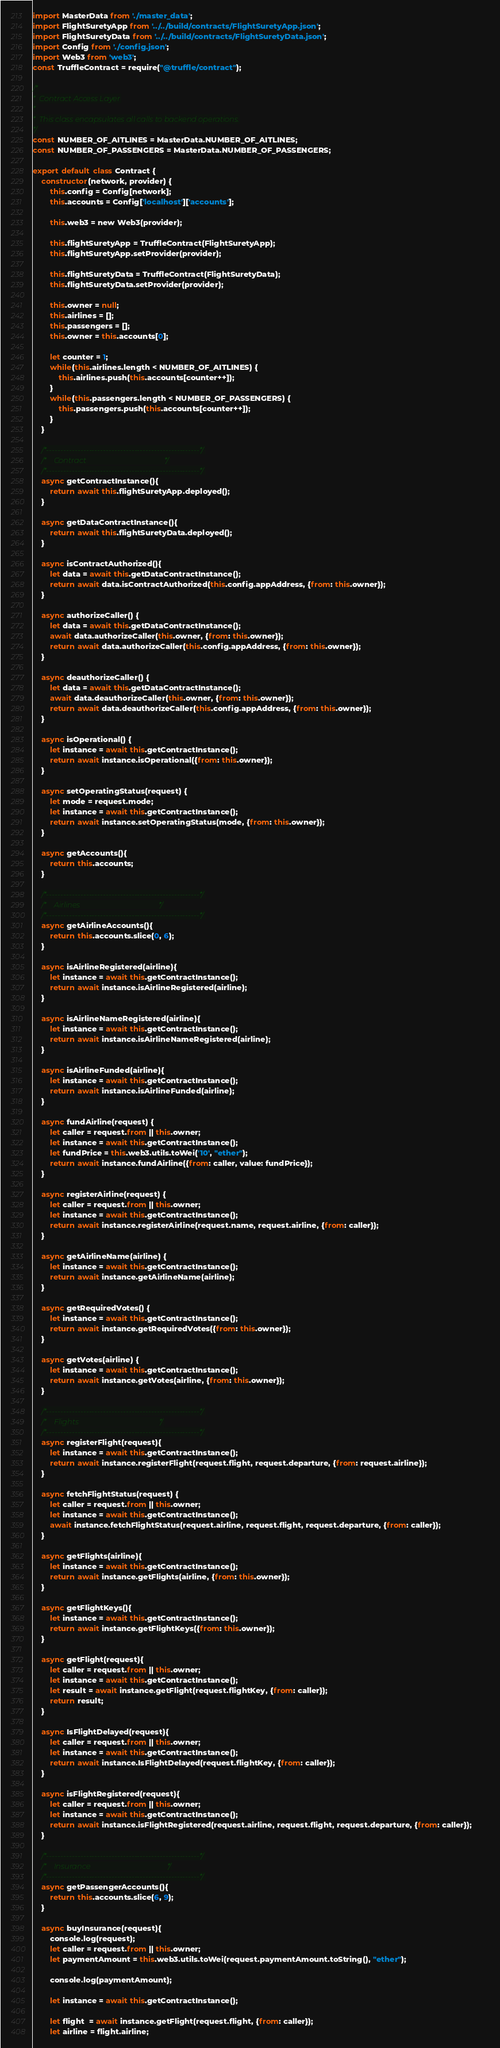Convert code to text. <code><loc_0><loc_0><loc_500><loc_500><_JavaScript_>import MasterData from './master_data';
import FlightSuretyApp from '../../build/contracts/FlightSuretyApp.json';
import FlightSuretyData from '../../build/contracts/FlightSuretyData.json';
import Config from './config.json';
import Web3 from 'web3';
const TruffleContract = require("@truffle/contract");

/*
*  Contract Access Layer
*
*  This class encapsulates all calls to backend operations.
*/
const NUMBER_OF_AITLINES = MasterData.NUMBER_OF_AITLINES;
const NUMBER_OF_PASSENGERS = MasterData.NUMBER_OF_PASSENGERS;

export default class Contract {
    constructor(network, provider) {
        this.config = Config[network];
        this.accounts = Config['localhost']['accounts'];

        this.web3 = new Web3(provider);

        this.flightSuretyApp = TruffleContract(FlightSuretyApp);
        this.flightSuretyApp.setProvider(provider);

        this.flightSuretyData = TruffleContract(FlightSuretyData);
        this.flightSuretyData.setProvider(provider);

        this.owner = null;
        this.airlines = [];
        this.passengers = [];
        this.owner = this.accounts[0];

        let counter = 1;
        while(this.airlines.length < NUMBER_OF_AITLINES) {
            this.airlines.push(this.accounts[counter++]);
        }
        while(this.passengers.length < NUMBER_OF_PASSENGERS) {
            this.passengers.push(this.accounts[counter++]);
        }
    }

    /*------------------------------------------------------*/
    /*    Contract                                          */
    /*------------------------------------------------------*/    
    async getContractInstance(){
        return await this.flightSuretyApp.deployed(); 
    }

    async getDataContractInstance(){
        return await this.flightSuretyData.deployed(); 
    }

    async isContractAuthorized(){
        let data = await this.getDataContractInstance();
        return await data.isContractAuthorized(this.config.appAddress, {from: this.owner});       
    }

    async authorizeCaller() {   
        let data = await this.getDataContractInstance();
        await data.authorizeCaller(this.owner, {from: this.owner});
        return await data.authorizeCaller(this.config.appAddress, {from: this.owner});
    }

    async deauthorizeCaller() {
        let data = await this.getDataContractInstance();
        await data.deauthorizeCaller(this.owner, {from: this.owner});
        return await data.deauthorizeCaller(this.config.appAddress, {from: this.owner});
    }    

    async isOperational() {
        let instance = await this.getContractInstance();
        return await instance.isOperational({from: this.owner});
    }

    async setOperatingStatus(request) {
        let mode = request.mode;
        let instance = await this.getContractInstance();
        return await instance.setOperatingStatus(mode, {from: this.owner});
    }

    async getAccounts(){
        return this.accounts;
    }

    /*------------------------------------------------------*/
    /*    Airlines                                          */
    /*------------------------------------------------------*/    
    async getAirlineAccounts(){
        return this.accounts.slice(0, 6);
    }

    async isAirlineRegistered(airline){
        let instance = await this.getContractInstance();
        return await instance.isAirlineRegistered(airline);        
    }

    async isAirlineNameRegistered(airline){
        let instance = await this.getContractInstance();
        return await instance.isAirlineNameRegistered(airline);        
    }

    async isAirlineFunded(airline){
        let instance = await this.getContractInstance();
        return await instance.isAirlineFunded(airline);        
    }

    async fundAirline(request) {
        let caller = request.from || this.owner;
        let instance = await this.getContractInstance();
        let fundPrice = this.web3.utils.toWei('10', "ether");
        return await instance.fundAirline({from: caller, value: fundPrice});
    }

    async registerAirline(request) {
        let caller = request.from || this.owner;
        let instance = await this.getContractInstance();
        return await instance.registerAirline(request.name, request.airline, {from: caller});
    }

    async getAirlineName(airline) {
        let instance = await this.getContractInstance();
        return await instance.getAirlineName(airline);
    }

    async getRequiredVotes() {
        let instance = await this.getContractInstance();
        return await instance.getRequiredVotes({from: this.owner});
    }

    async getVotes(airline) {
        let instance = await this.getContractInstance();
        return await instance.getVotes(airline, {from: this.owner});
    }

    /*------------------------------------------------------*/
    /*    Flights                                           */
    /*------------------------------------------------------*/ 
    async registerFlight(request){
        let instance = await this.getContractInstance();
        return await instance.registerFlight(request.flight, request.departure, {from: request.airline});
    }
   
    async fetchFlightStatus(request) {
        let caller = request.from || this.owner;
        let instance = await this.getContractInstance();
        await instance.fetchFlightStatus(request.airline, request.flight, request.departure, {from: caller});
    }

    async getFlights(airline){
        let instance = await this.getContractInstance();
        return await instance.getFlights(airline, {from: this.owner});
    }

    async getFlightKeys(){
        let instance = await this.getContractInstance();
        return await instance.getFlightKeys({from: this.owner});
    }

    async getFlight(request){
        let caller = request.from || this.owner;
        let instance = await this.getContractInstance();
        let result = await instance.getFlight(request.flightKey, {from: caller});
        return result;
    }

    async IsFlightDelayed(request){
        let caller = request.from || this.owner;
        let instance = await this.getContractInstance();
        return await instance.IsFlightDelayed(request.flightKey, {from: caller});
    }

    async isFlightRegistered(request){
        let caller = request.from || this.owner;
        let instance = await this.getContractInstance();
        return await instance.isFlightRegistered(request.airline, request.flight, request.departure, {from: caller});        
    }

    /*------------------------------------------------------*/
    /*    Insurance                                         */
    /*------------------------------------------------------*/    
    async getPassengerAccounts(){
        return this.accounts.slice(6, 9);
    }

    async buyInsurance(request){
        console.log(request);
        let caller = request.from || this.owner;
        let paymentAmount = this.web3.utils.toWei(request.paymentAmount.toString(), "ether");
        
        console.log(paymentAmount);

        let instance = await this.getContractInstance();

        let flight  = await instance.getFlight(request.flight, {from: caller});
        let airline = flight.airline;</code> 